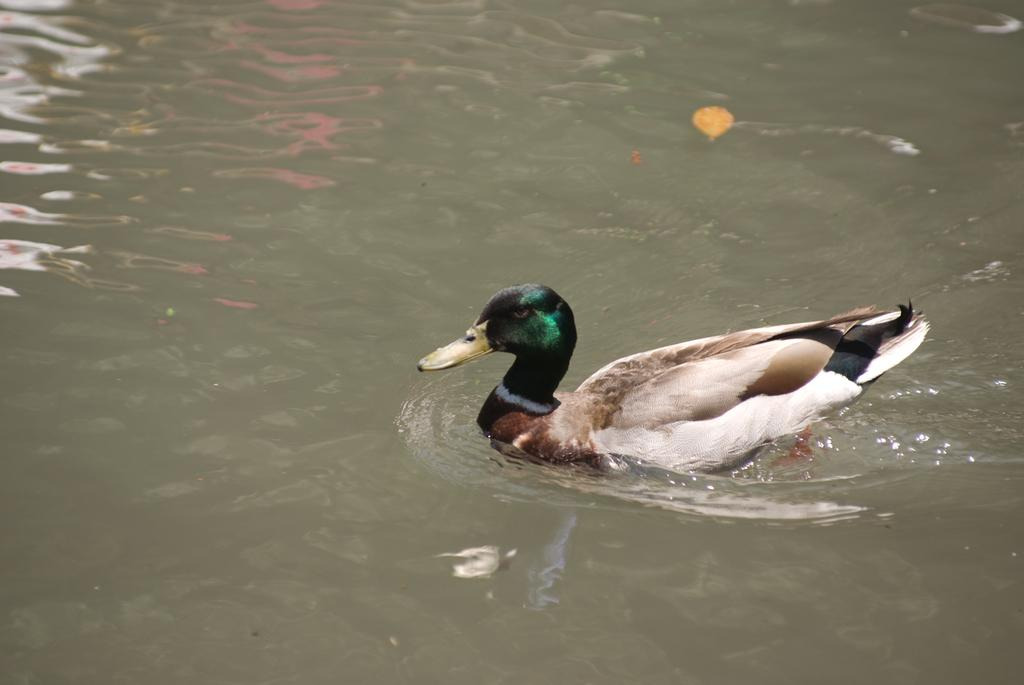What type of animal is in the image? There is a duck in the image. Where is the duck located in the image? The duck is in the water. What type of activity are the oranges participating in with the crowd in the image? There are no oranges or crowd present in the image; it features a duck in the water. 